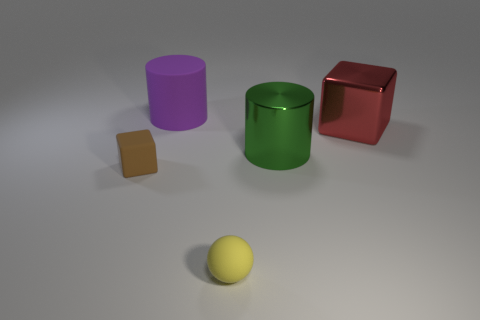Subtract all spheres. How many objects are left? 4 Subtract 1 cylinders. How many cylinders are left? 1 Add 1 large metallic blocks. How many objects exist? 6 Subtract all brown cubes. Subtract all yellow spheres. How many cubes are left? 1 Subtract all metal cylinders. Subtract all cyan matte cubes. How many objects are left? 4 Add 2 small balls. How many small balls are left? 3 Add 4 large shiny cubes. How many large shiny cubes exist? 5 Subtract 1 yellow balls. How many objects are left? 4 